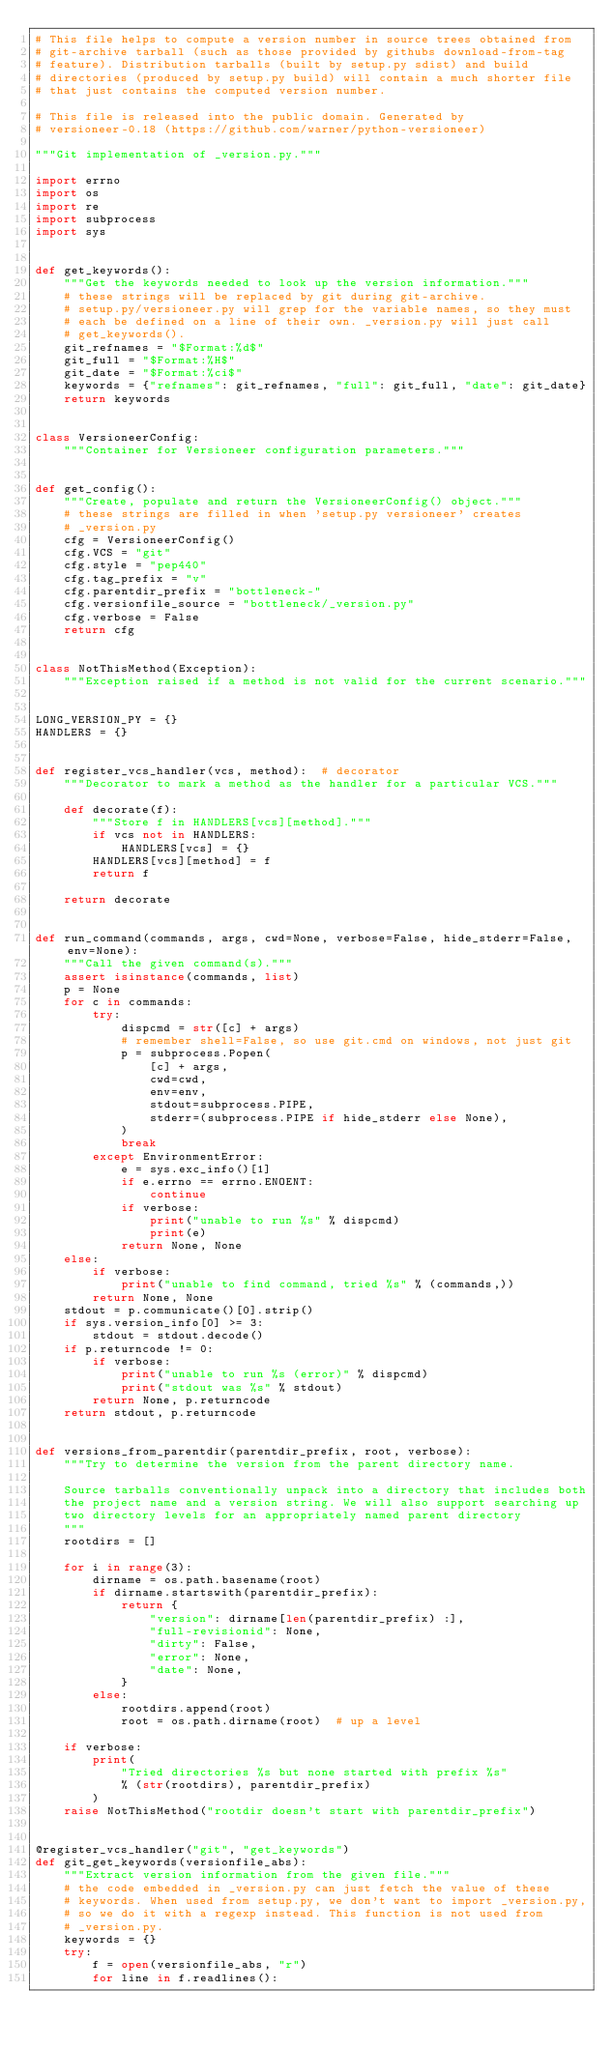Convert code to text. <code><loc_0><loc_0><loc_500><loc_500><_Python_># This file helps to compute a version number in source trees obtained from
# git-archive tarball (such as those provided by githubs download-from-tag
# feature). Distribution tarballs (built by setup.py sdist) and build
# directories (produced by setup.py build) will contain a much shorter file
# that just contains the computed version number.

# This file is released into the public domain. Generated by
# versioneer-0.18 (https://github.com/warner/python-versioneer)

"""Git implementation of _version.py."""

import errno
import os
import re
import subprocess
import sys


def get_keywords():
    """Get the keywords needed to look up the version information."""
    # these strings will be replaced by git during git-archive.
    # setup.py/versioneer.py will grep for the variable names, so they must
    # each be defined on a line of their own. _version.py will just call
    # get_keywords().
    git_refnames = "$Format:%d$"
    git_full = "$Format:%H$"
    git_date = "$Format:%ci$"
    keywords = {"refnames": git_refnames, "full": git_full, "date": git_date}
    return keywords


class VersioneerConfig:
    """Container for Versioneer configuration parameters."""


def get_config():
    """Create, populate and return the VersioneerConfig() object."""
    # these strings are filled in when 'setup.py versioneer' creates
    # _version.py
    cfg = VersioneerConfig()
    cfg.VCS = "git"
    cfg.style = "pep440"
    cfg.tag_prefix = "v"
    cfg.parentdir_prefix = "bottleneck-"
    cfg.versionfile_source = "bottleneck/_version.py"
    cfg.verbose = False
    return cfg


class NotThisMethod(Exception):
    """Exception raised if a method is not valid for the current scenario."""


LONG_VERSION_PY = {}
HANDLERS = {}


def register_vcs_handler(vcs, method):  # decorator
    """Decorator to mark a method as the handler for a particular VCS."""

    def decorate(f):
        """Store f in HANDLERS[vcs][method]."""
        if vcs not in HANDLERS:
            HANDLERS[vcs] = {}
        HANDLERS[vcs][method] = f
        return f

    return decorate


def run_command(commands, args, cwd=None, verbose=False, hide_stderr=False, env=None):
    """Call the given command(s)."""
    assert isinstance(commands, list)
    p = None
    for c in commands:
        try:
            dispcmd = str([c] + args)
            # remember shell=False, so use git.cmd on windows, not just git
            p = subprocess.Popen(
                [c] + args,
                cwd=cwd,
                env=env,
                stdout=subprocess.PIPE,
                stderr=(subprocess.PIPE if hide_stderr else None),
            )
            break
        except EnvironmentError:
            e = sys.exc_info()[1]
            if e.errno == errno.ENOENT:
                continue
            if verbose:
                print("unable to run %s" % dispcmd)
                print(e)
            return None, None
    else:
        if verbose:
            print("unable to find command, tried %s" % (commands,))
        return None, None
    stdout = p.communicate()[0].strip()
    if sys.version_info[0] >= 3:
        stdout = stdout.decode()
    if p.returncode != 0:
        if verbose:
            print("unable to run %s (error)" % dispcmd)
            print("stdout was %s" % stdout)
        return None, p.returncode
    return stdout, p.returncode


def versions_from_parentdir(parentdir_prefix, root, verbose):
    """Try to determine the version from the parent directory name.

    Source tarballs conventionally unpack into a directory that includes both
    the project name and a version string. We will also support searching up
    two directory levels for an appropriately named parent directory
    """
    rootdirs = []

    for i in range(3):
        dirname = os.path.basename(root)
        if dirname.startswith(parentdir_prefix):
            return {
                "version": dirname[len(parentdir_prefix) :],
                "full-revisionid": None,
                "dirty": False,
                "error": None,
                "date": None,
            }
        else:
            rootdirs.append(root)
            root = os.path.dirname(root)  # up a level

    if verbose:
        print(
            "Tried directories %s but none started with prefix %s"
            % (str(rootdirs), parentdir_prefix)
        )
    raise NotThisMethod("rootdir doesn't start with parentdir_prefix")


@register_vcs_handler("git", "get_keywords")
def git_get_keywords(versionfile_abs):
    """Extract version information from the given file."""
    # the code embedded in _version.py can just fetch the value of these
    # keywords. When used from setup.py, we don't want to import _version.py,
    # so we do it with a regexp instead. This function is not used from
    # _version.py.
    keywords = {}
    try:
        f = open(versionfile_abs, "r")
        for line in f.readlines():</code> 